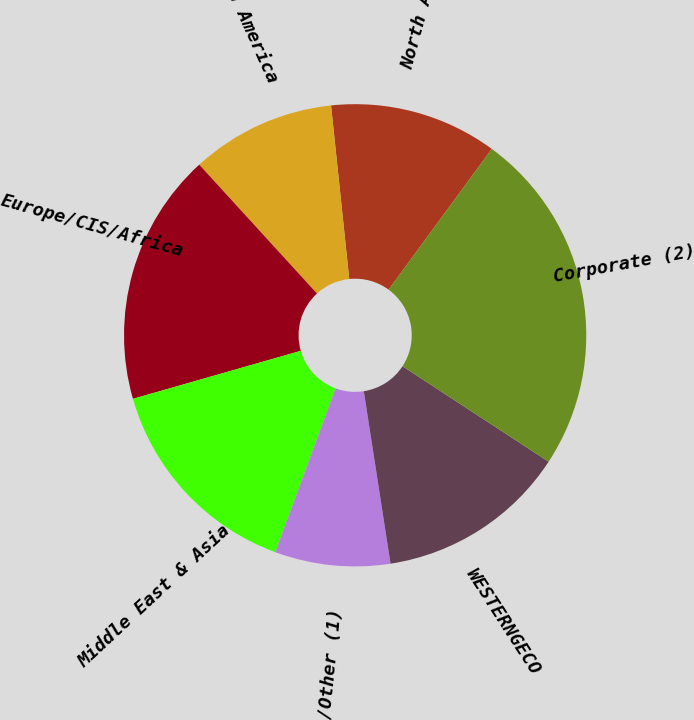Convert chart. <chart><loc_0><loc_0><loc_500><loc_500><pie_chart><fcel>North America<fcel>Latin America<fcel>Europe/CIS/Africa<fcel>Middle East & Asia<fcel>Elims/Other (1)<fcel>WESTERNGECO<fcel>Corporate (2)<nl><fcel>11.73%<fcel>10.12%<fcel>17.65%<fcel>14.95%<fcel>8.06%<fcel>13.34%<fcel>24.14%<nl></chart> 